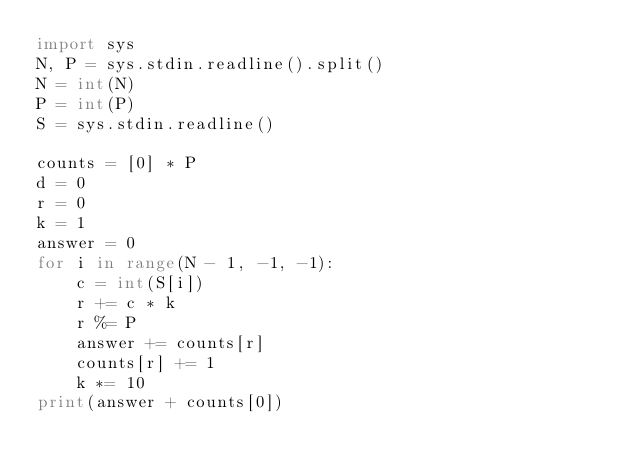Convert code to text. <code><loc_0><loc_0><loc_500><loc_500><_Python_>import sys
N, P = sys.stdin.readline().split()
N = int(N)
P = int(P)
S = sys.stdin.readline()

counts = [0] * P
d = 0
r = 0
k = 1
answer = 0
for i in range(N - 1, -1, -1):
    c = int(S[i])
    r += c * k
    r %= P
    answer += counts[r]
    counts[r] += 1
    k *= 10
print(answer + counts[0])
</code> 